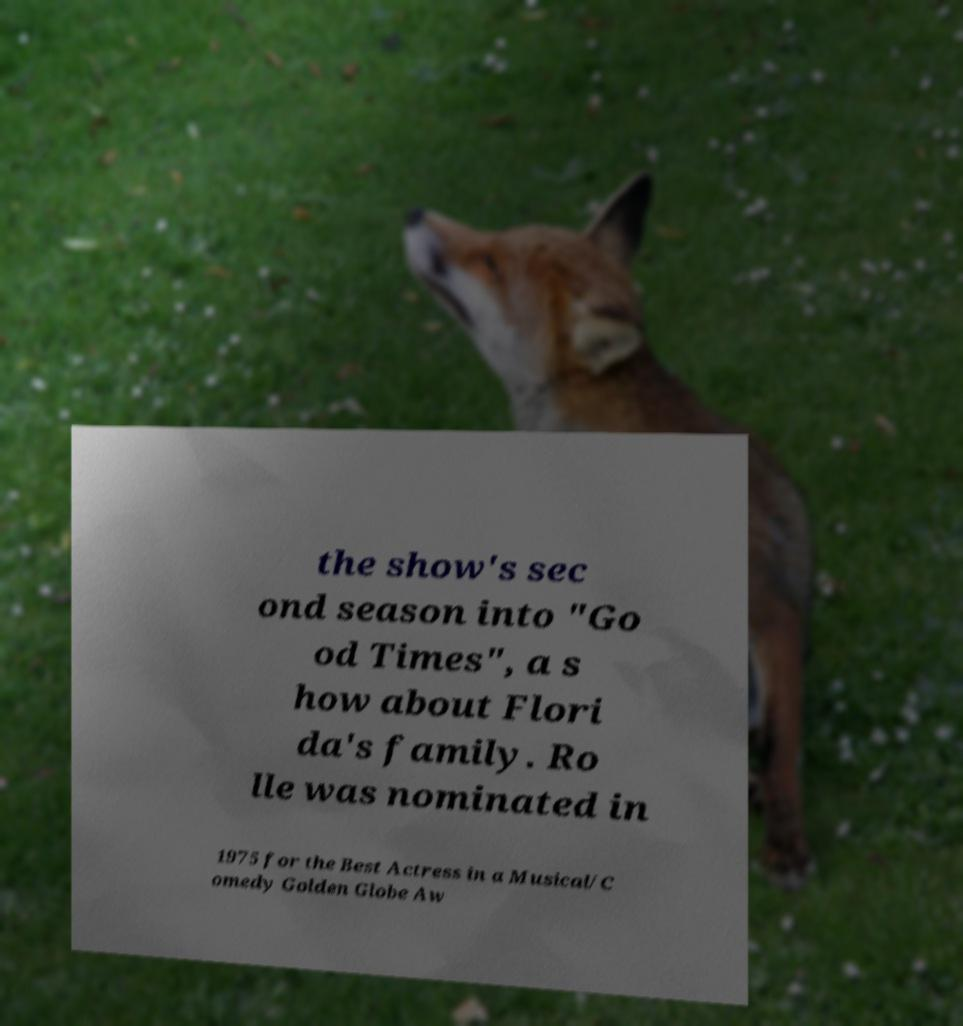Can you read and provide the text displayed in the image?This photo seems to have some interesting text. Can you extract and type it out for me? the show's sec ond season into "Go od Times", a s how about Flori da's family. Ro lle was nominated in 1975 for the Best Actress in a Musical/C omedy Golden Globe Aw 